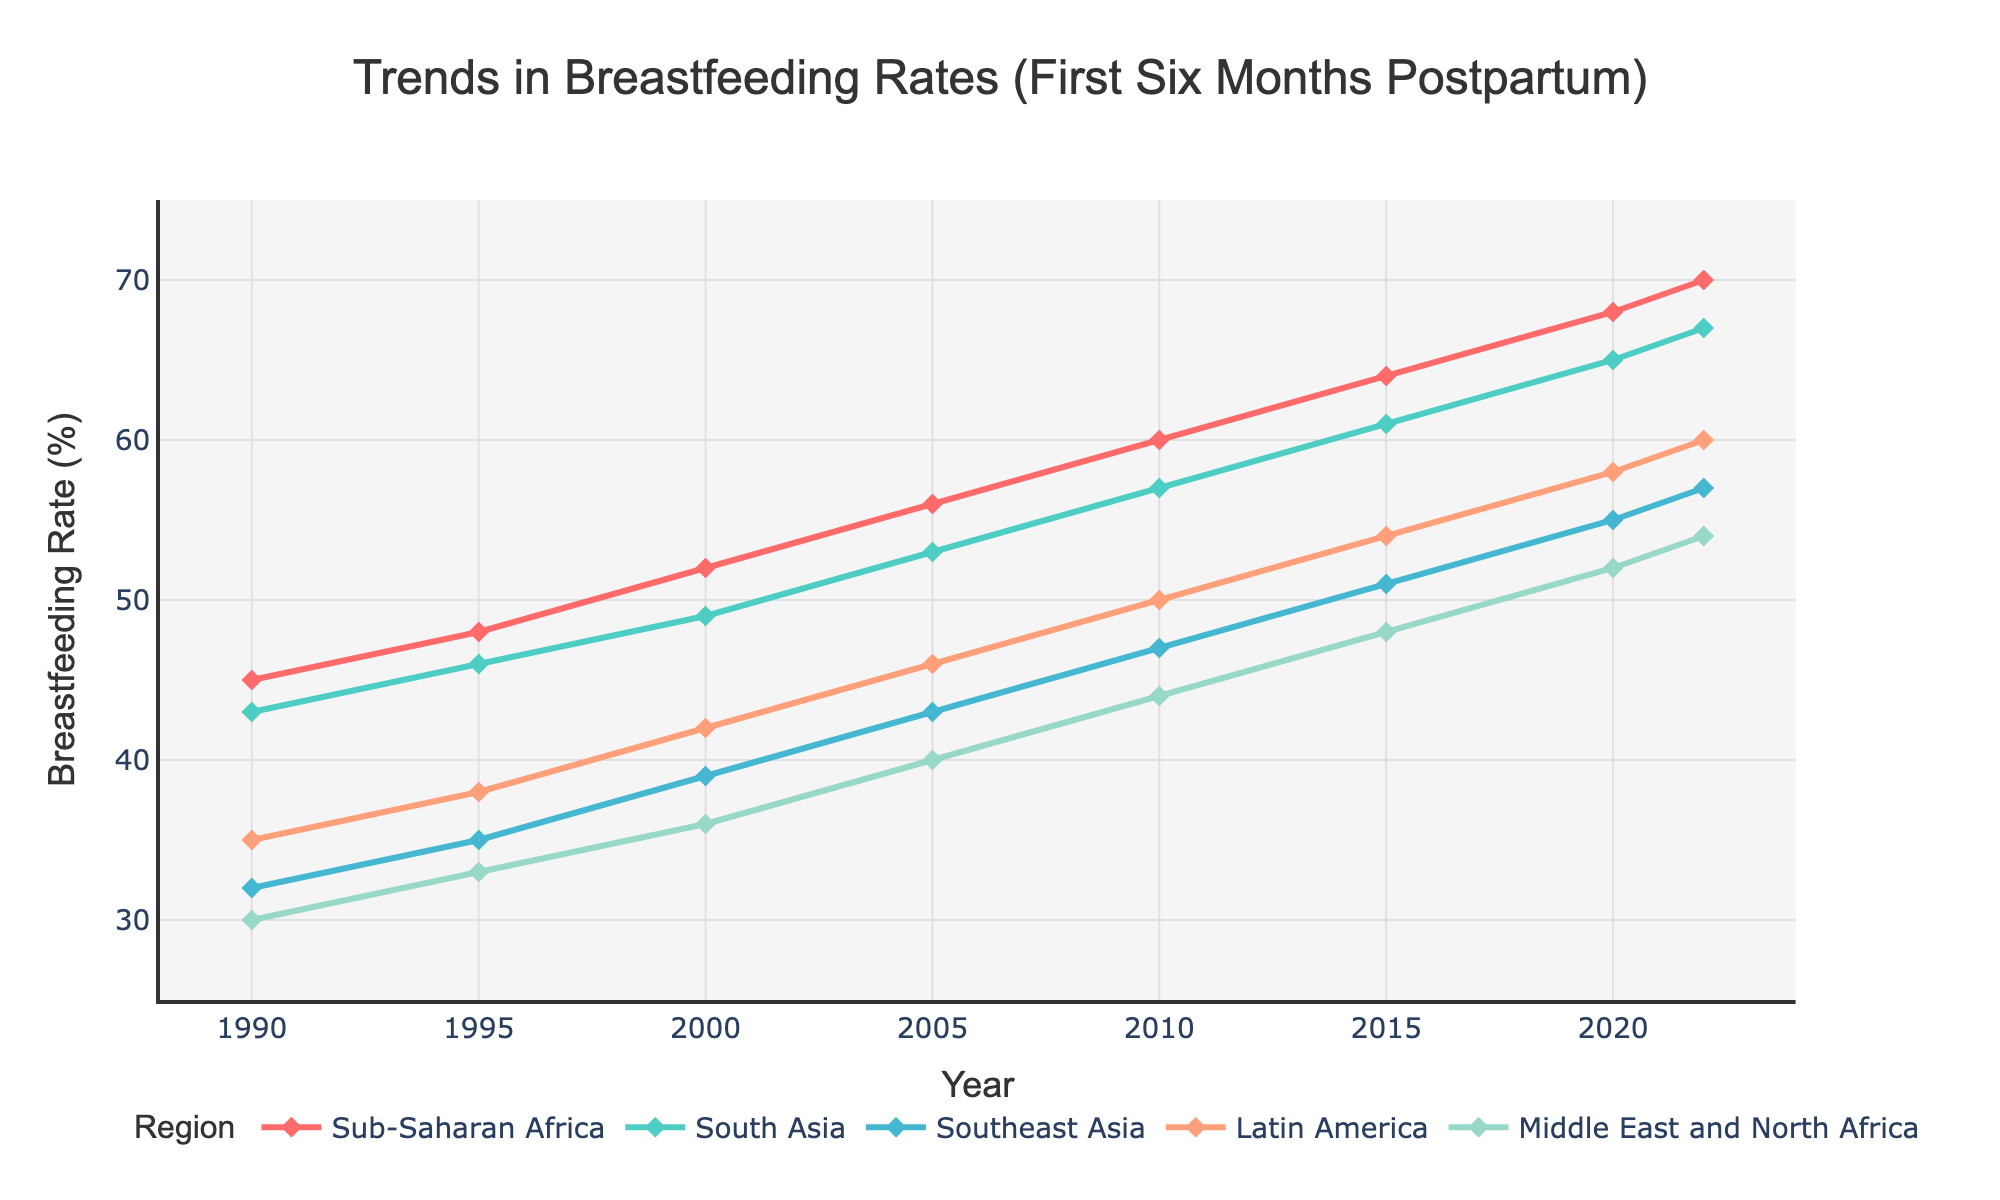what was the trend in breastfeeding rates in Sub-Saharan Africa from 1990 to 2022? To identify the trend, look at the data points for Sub-Saharan Africa from 1990 to 2022. In 1990, it was 45%, and it steadily increased to 70% by 2022. This shows a consistent upward trend.
Answer: consistent upward trend which region had the highest breastfeeding rate in 2022? Compare the breastfeeding rates for all regions in the year 2022. Sub-Saharan Africa leads with 70%, followed by South Asia, Southeast Asia, Latin America, and Middle East and North Africa.
Answer: Sub-Saharan Africa between which consecutive years did South Asia see the largest increase in breastfeeding rates? By examining the data points for South Asia, the increases are as follows: 1990-1995 (+3), 1995-2000 (+3), 2000-2005 (+4), 2005-2010 (+4), 2010-2015 (+4), 2015-2020 (+4), and 2020-2022 (+2). The largest increases were between 2000-2005, 2005-2010, 2010-2015, and 2015-2020, all at +4%.
Answer: 2000 to 2005, 2005 to 2010, 2010 to 2015, and 2015 to 2020 how much did breastfeeding rates in Latin America increase from 2000 to 2020? In Latin America, the breastfeeding rates were 42% in 2000 and 58% in 2020. The increase is 58 - 42 = 16%.
Answer: 16% which region had the smallest breastfeeding rate in 1995, and what was the rate? Look at the breastfeeding rates for all regions in 1995. The Middle East and North Africa had the smallest rate, with 33%.
Answer: Middle East and North Africa, 33% how did the breastfeeding rates change in the Middle East and North Africa from 1990 to 2022? Observing the data points for the Middle East and North Africa: 30% (1990), 33% (1995), 36% (2000), 40% (2005), 44% (2010), 48% (2015), 52% (2020), 54% (2022), it consistently increased over the years from 30% to 54%.
Answer: consistent increase 